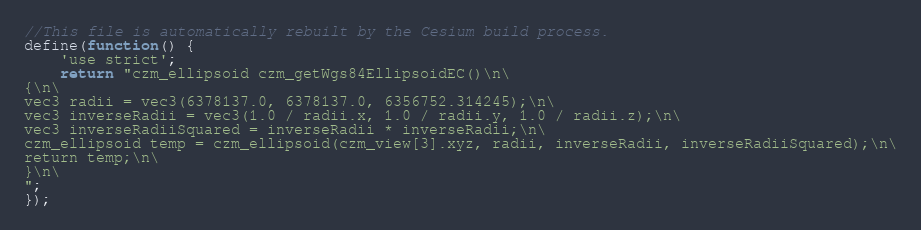<code> <loc_0><loc_0><loc_500><loc_500><_JavaScript_>//This file is automatically rebuilt by the Cesium build process.
define(function() {
    'use strict';
    return "czm_ellipsoid czm_getWgs84EllipsoidEC()\n\
{\n\
vec3 radii = vec3(6378137.0, 6378137.0, 6356752.314245);\n\
vec3 inverseRadii = vec3(1.0 / radii.x, 1.0 / radii.y, 1.0 / radii.z);\n\
vec3 inverseRadiiSquared = inverseRadii * inverseRadii;\n\
czm_ellipsoid temp = czm_ellipsoid(czm_view[3].xyz, radii, inverseRadii, inverseRadiiSquared);\n\
return temp;\n\
}\n\
";
});</code> 